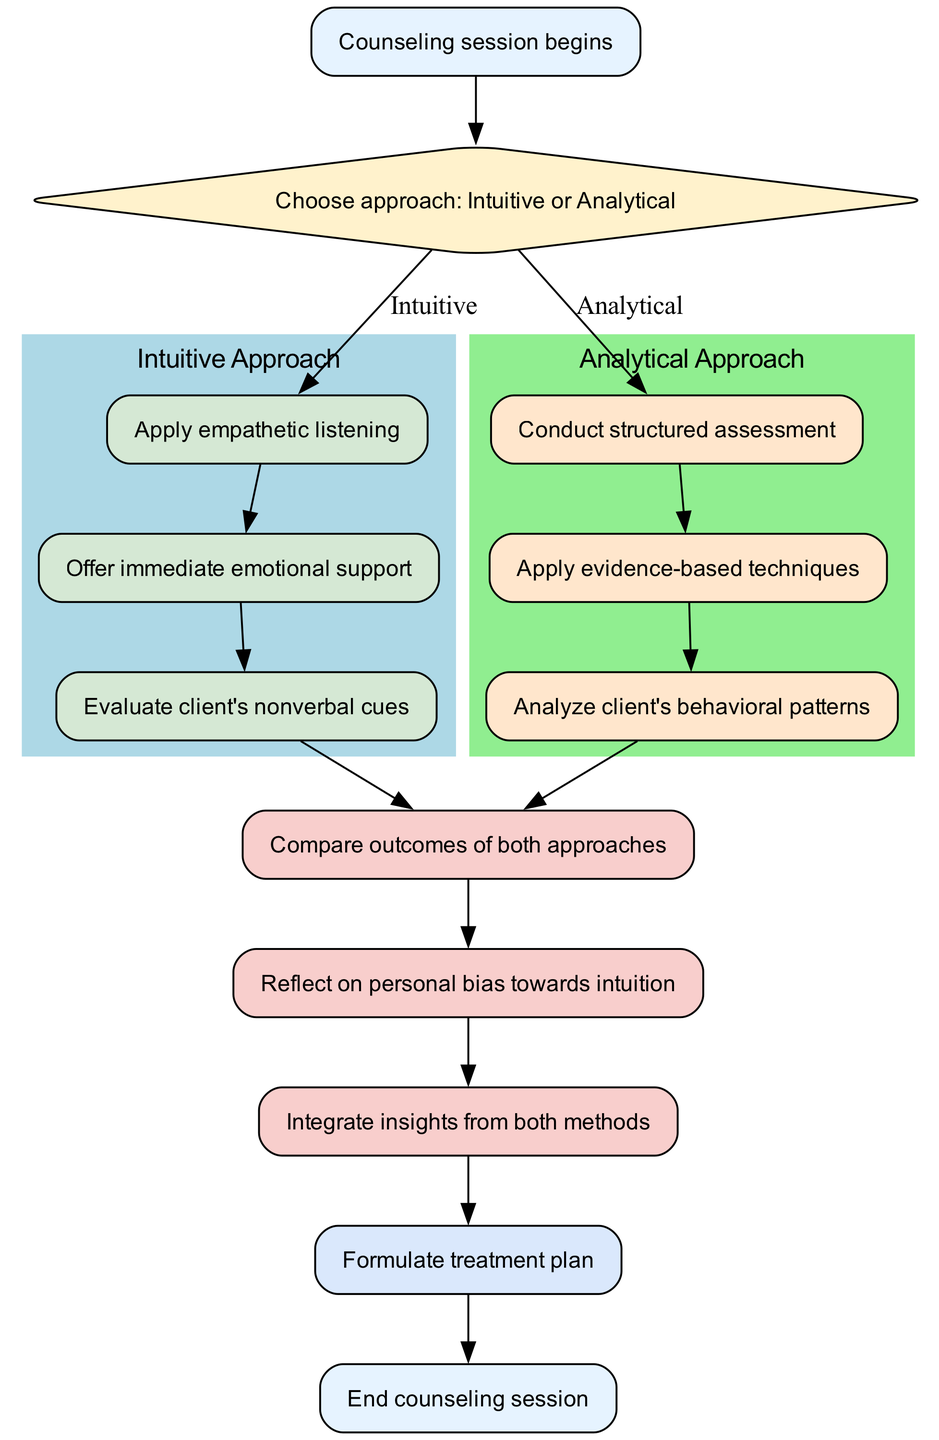What is the initial node in the diagram? The initial node is labeled "Counseling session begins." It is the first node that indicates where the flowchart starts.
Answer: Counseling session begins How many approaches are shown in the decision node? The decision node presents two approaches: "Intuitive" and "Analytical." The presence of both paths indicates that the options involve these two distinct methods.
Answer: Two What is the action taken under the intuitive approach? The action node under the intuitive approach is labeled "Offer immediate emotional support." This indicates the specific action to be taken following the intuitive process.
Answer: Offer immediate emotional support What follows the assessment of the analytical approach? After "Analyze client's behavioral patterns" in the analytical assessment, the next node is "Compare outcomes of both approaches." The flow continues with this comparison as the next step after the assessment.
Answer: Compare outcomes of both approaches What is required after comparing the outcomes of both approaches? After comparing, the next node is "Reflect on personal bias towards intuition." This reflection is a required step following the comparison to consider personal influences on decision-making.
Answer: Reflect on personal bias towards intuition Which color represents the intuitive approach processes? The intuitive approach processes are represented in the color light blue, indicated by the filled color of the subgraph. This distinct color helps differentiate it from the analytical approach in the diagram.
Answer: Light blue What is the final node in the flowchart? The final node in the flowchart is labeled "End counseling session." This indicates the conclusion of the flowchart process.
Answer: End counseling session How do both approaches lead to the conclusion? Both approaches lead to the conclusion through the "Compare outcomes of both approaches," followed by "Reflect on personal bias towards intuition," and then "Integrate insights from both methods" before arriving at the conclusion step. This sequence shows how insights from both paths are needed to formulate a treatment plan.
Answer: By comparing, reflecting, and integrating insights from both methods What does the diagram imply about the decision-making process in counseling? The diagram implies that the decision-making process in counseling involves selecting between intuitive and analytical approaches, reflecting on biases, and integrating insights before concluding the treatment plan. It highlights a structured yet flexible process to accommodate both methods.
Answer: Structured yet flexible process 